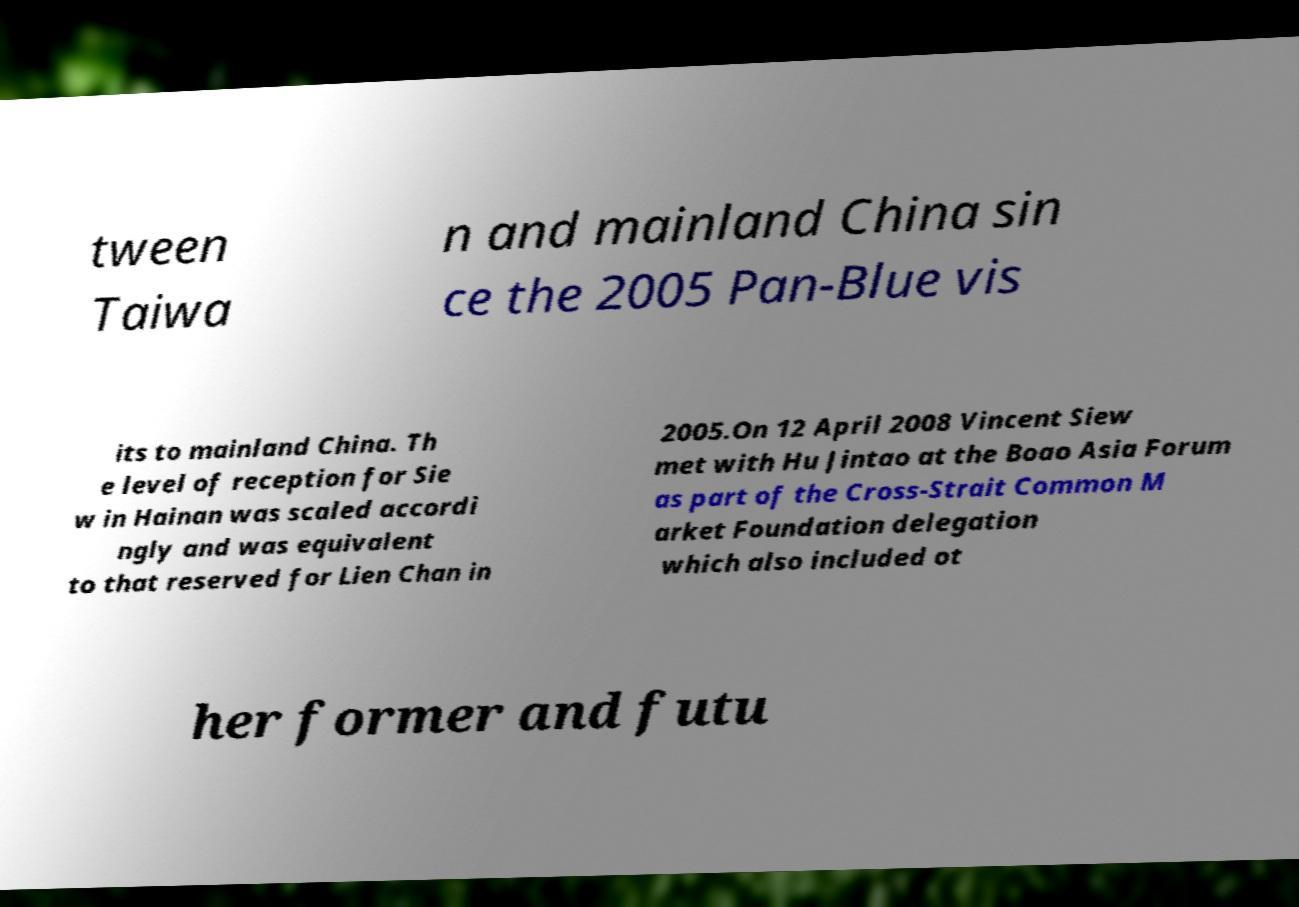Could you extract and type out the text from this image? tween Taiwa n and mainland China sin ce the 2005 Pan-Blue vis its to mainland China. Th e level of reception for Sie w in Hainan was scaled accordi ngly and was equivalent to that reserved for Lien Chan in 2005.On 12 April 2008 Vincent Siew met with Hu Jintao at the Boao Asia Forum as part of the Cross-Strait Common M arket Foundation delegation which also included ot her former and futu 